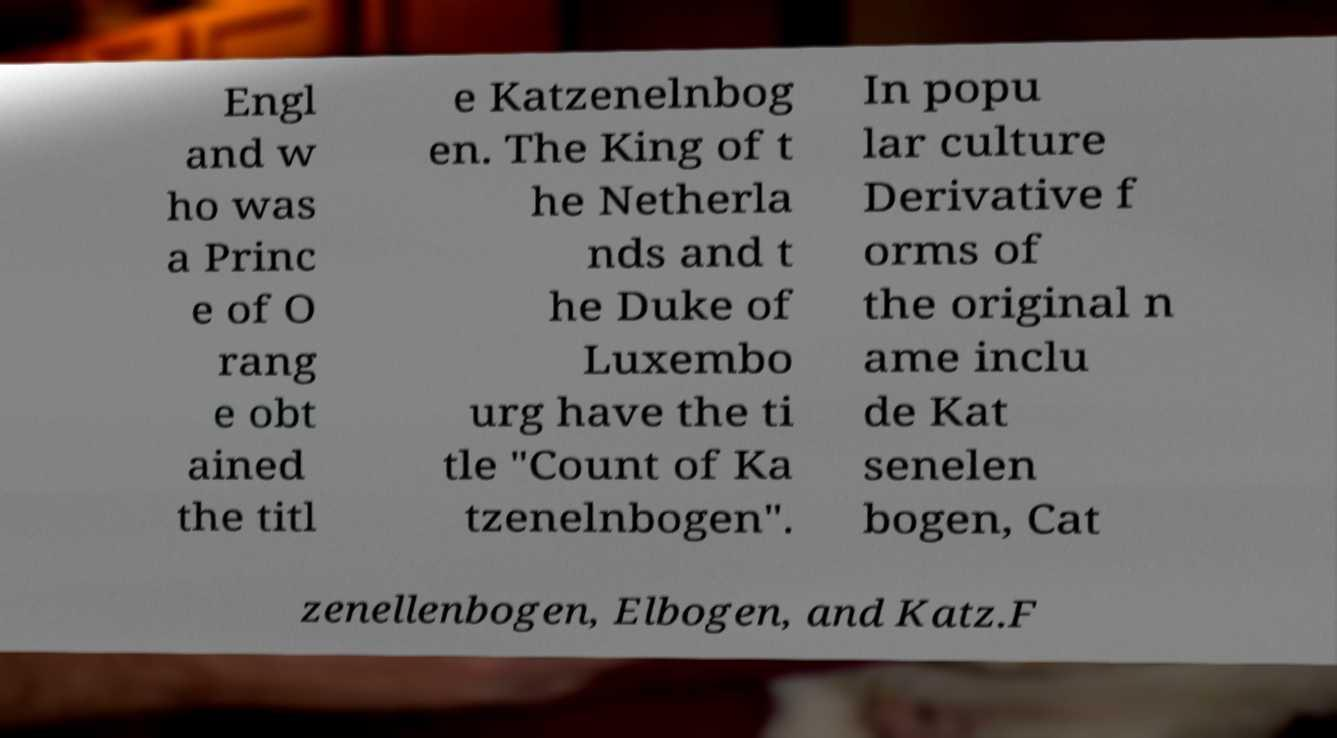For documentation purposes, I need the text within this image transcribed. Could you provide that? Engl and w ho was a Princ e of O rang e obt ained the titl e Katzenelnbog en. The King of t he Netherla nds and t he Duke of Luxembo urg have the ti tle "Count of Ka tzenelnbogen". In popu lar culture Derivative f orms of the original n ame inclu de Kat senelen bogen, Cat zenellenbogen, Elbogen, and Katz.F 